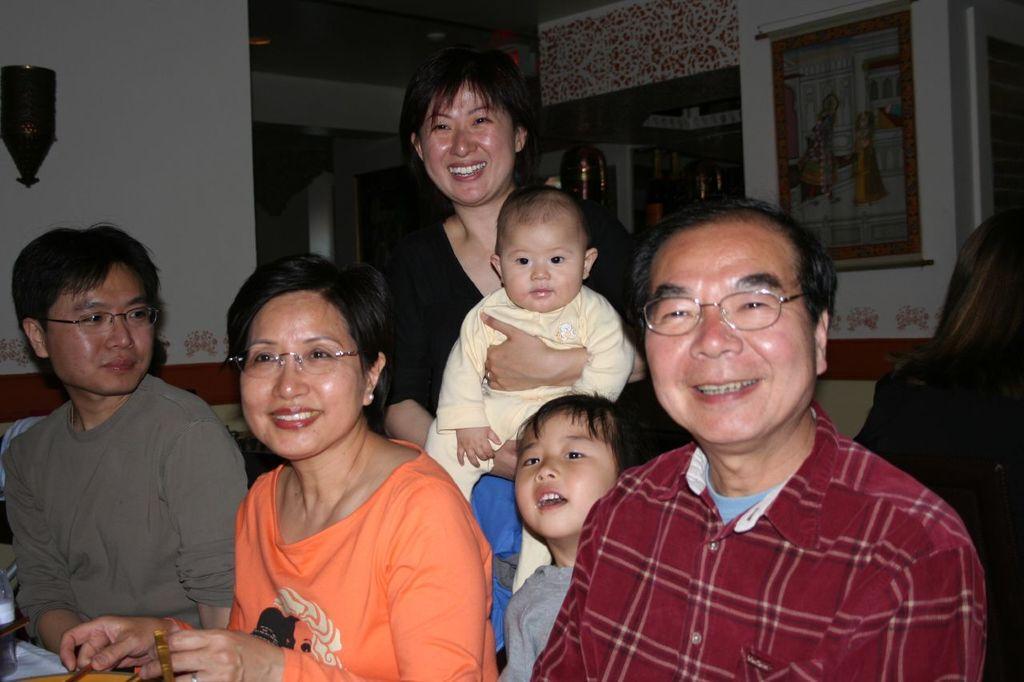Could you give a brief overview of what you see in this image? In this image we can see a group of people posing for a picture, one among them is carrying a baby, behind them there is a painting, a wall decor and a few other objects. 